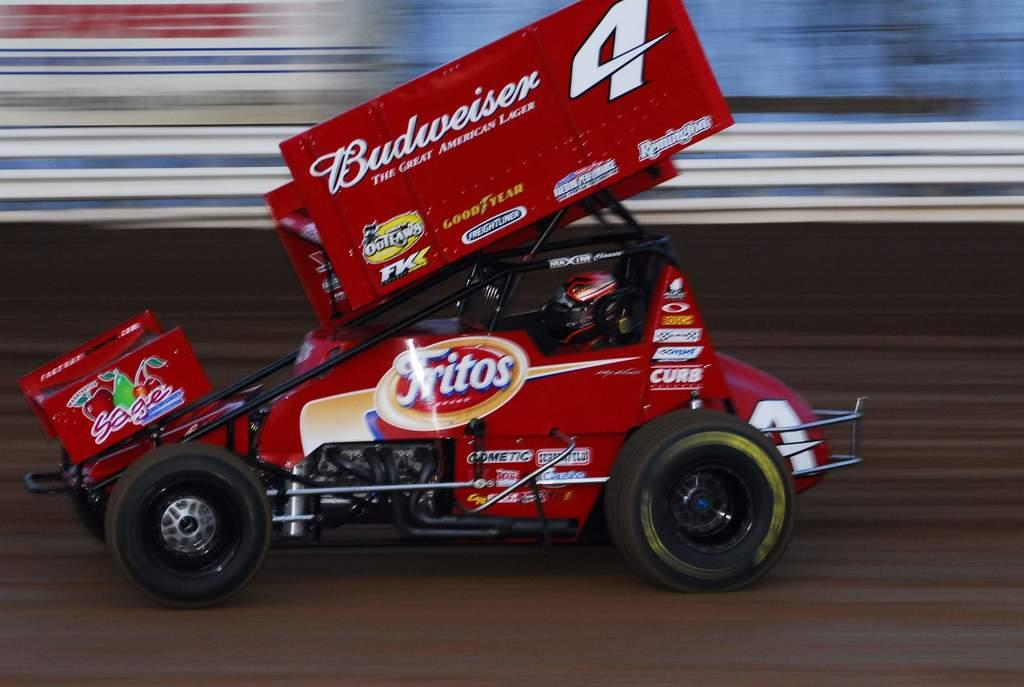Who or what is the main subject in the image? There is a person in the image. What is the person doing in the image? The person is riding a vehicle. Can you describe the surface the vehicle is on? The vehicle is on a surface, but the specific type of surface is not mentioned in the facts. How would you describe the background of the image? The background of the image is blurred. What type of flowers can be seen growing near the person in the image? There is no mention of flowers in the image, so we cannot determine if any are present. 